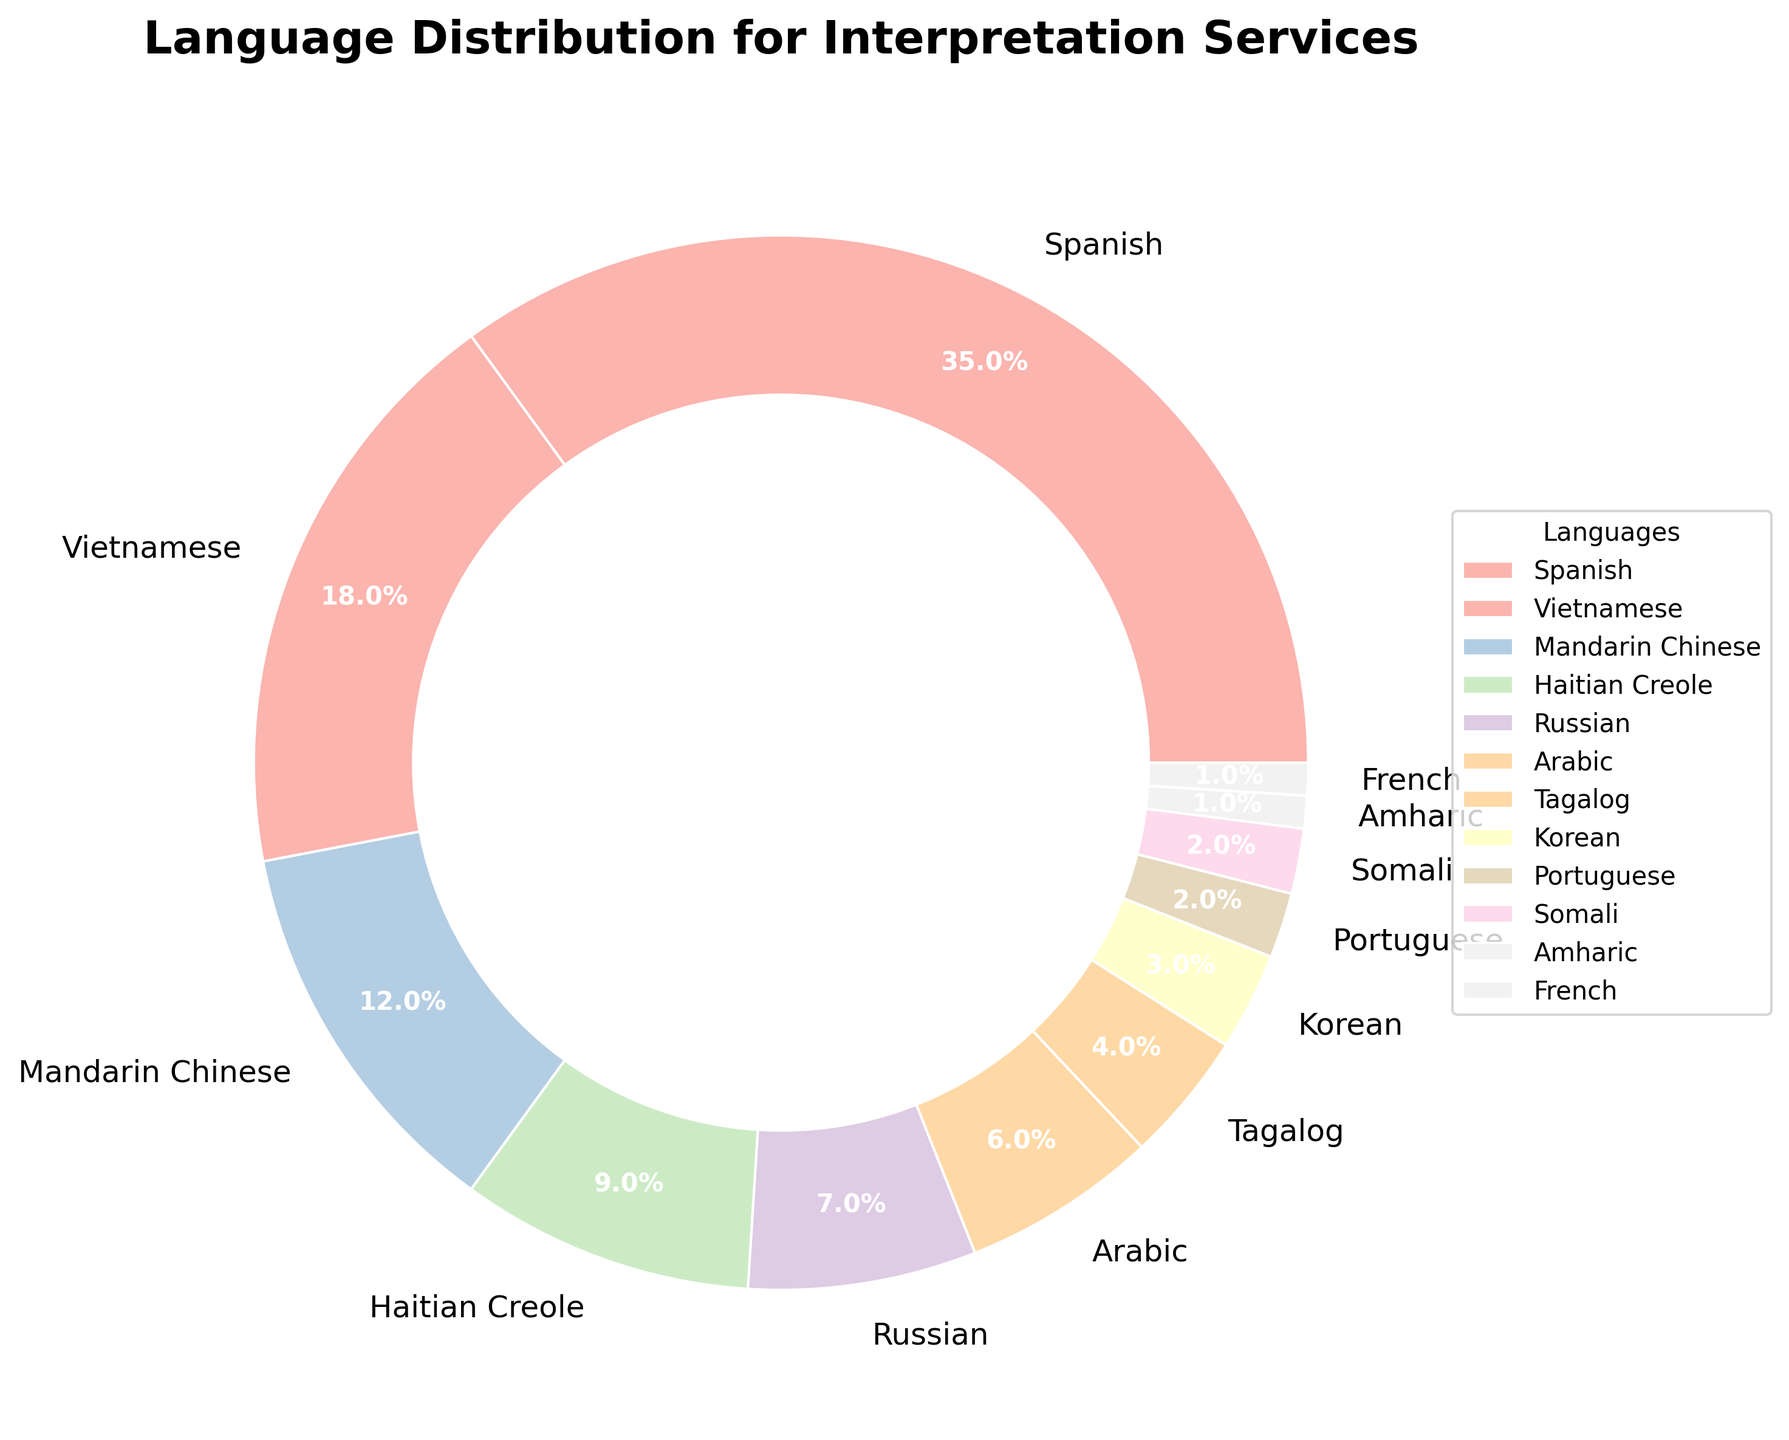What percentage of the community members require Spanish interpretation services? The Spanish slice in the pie chart has a label indicating it covers 35% of the total interpretation services needed.
Answer: 35% Which language has the lowest percentage of community members needing interpretation services? By looking at the pie chart, the smallest slices represent Portuguese, Somali, Amharic, and French; each is marked with a small percentage. Amharic and French have the smallest percentages of 1%.
Answer: Amharic and French How many languages require interpretation services for at least 10% of the community members? Observing the pie chart, Spanish (35%), Vietnamese (18%), and Mandarin Chinese (12%) each cover more than 10% of the needs, which adds up to 3 languages.
Answer: 3 What is the combined percentage of community members that need interpretation services for Arabic and Tagalog? The pie chart shows Arabic at 6% and Tagalog at 4%. Summing these percentages: 6% + 4% = 10%.
Answer: 10% Which language has a higher demand for interpretation services, Russian or Korean? The pie chart shows Russian at 7% and Korean at 3%. Comparing these percentages, Russian is higher.
Answer: Russian Are there more people requiring interpretation services for Mandarin Chinese or Haitian Creole? According to the pie chart, Mandarin Chinese stands at 12% and Haitian Creole at 9%. Thus, more people require interpretation services for Mandarin Chinese.
Answer: Mandarin Chinese How do the percentages for interpretation services for Spanish and Vietnamese compare? The pie chart indicates Spanish at 35% and Vietnamese at 18%. The percentage for Spanish is almost double that of Vietnamese (35% > 18%).
Answer: Spanish is almost double Vietnamese What is the total percentage of community members requiring interpretation services for languages other than Spanish? First, identify the percentage for Spanish (35%), then sum the remaining percentages: 100% - 35% = 65%.
Answer: 65% What's the difference in percentage between the highest and lowest sectors in the pie chart? The highest sector is Spanish at 35%, and the lowest sectors are Amharic and French at 1%. The difference is 35% - 1% = 34%.
Answer: 34% What is the sum of the percentages for languages above 5%? The pie chart shows languages above 5% as Spanish (35%), Vietnamese (18%), Mandarin Chinese (12%), Haitian Creole (9%), Russian (7%), and Arabic (6%). Summing these: 35% + 18% + 12% + 9% + 7% + 6% = 87%.
Answer: 87% 